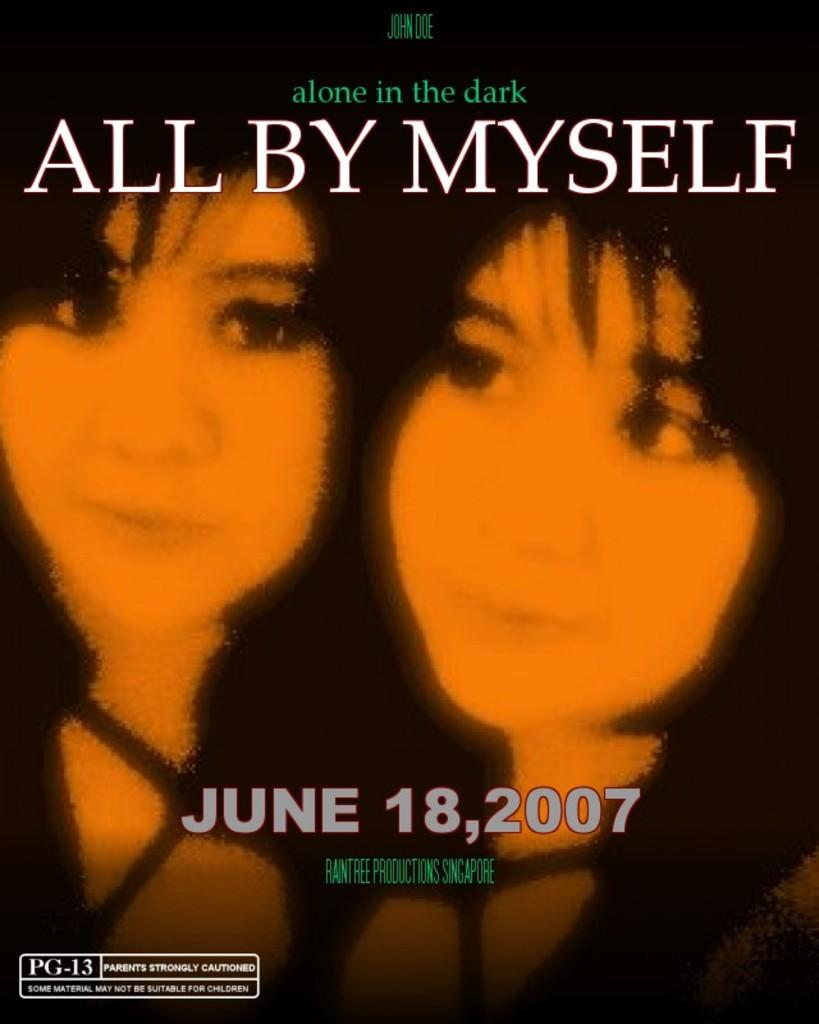What is present on the poster in the image? The poster contains text and a drawing. Can you describe the drawing on the poster? Unfortunately, the facts provided do not give any details about the drawing on the poster. What is the purpose of the text on the poster? The purpose of the text on the poster cannot be determined from the given facts. What type of stove is used to cook the popcorn in the image? There is no stove or popcorn present in the image. What show is being advertised on the poster in the image? The facts provided do not give any information about a show being advertised on the poster. 